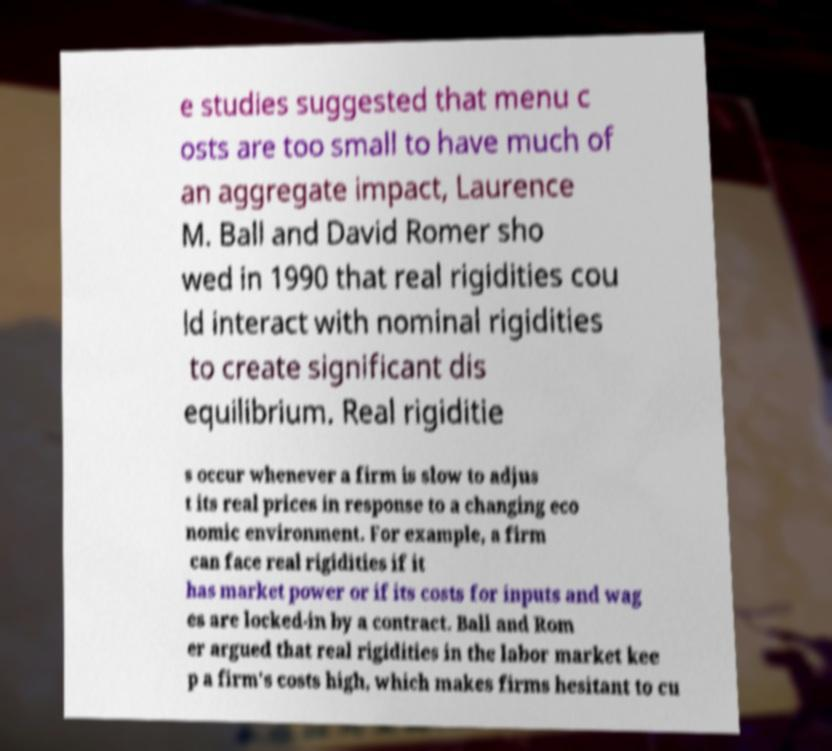Could you assist in decoding the text presented in this image and type it out clearly? e studies suggested that menu c osts are too small to have much of an aggregate impact, Laurence M. Ball and David Romer sho wed in 1990 that real rigidities cou ld interact with nominal rigidities to create significant dis equilibrium. Real rigiditie s occur whenever a firm is slow to adjus t its real prices in response to a changing eco nomic environment. For example, a firm can face real rigidities if it has market power or if its costs for inputs and wag es are locked-in by a contract. Ball and Rom er argued that real rigidities in the labor market kee p a firm's costs high, which makes firms hesitant to cu 